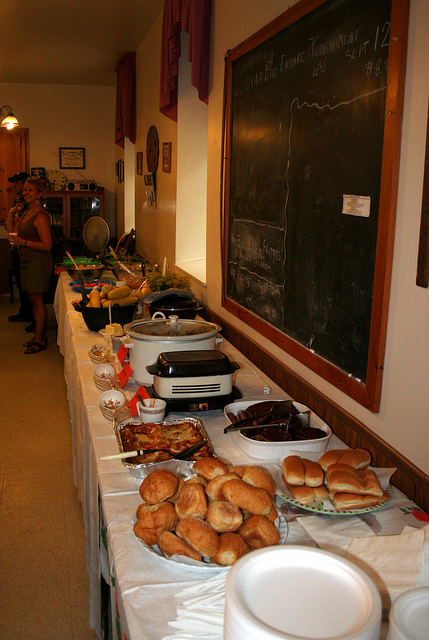Read all the text in this image. 12 